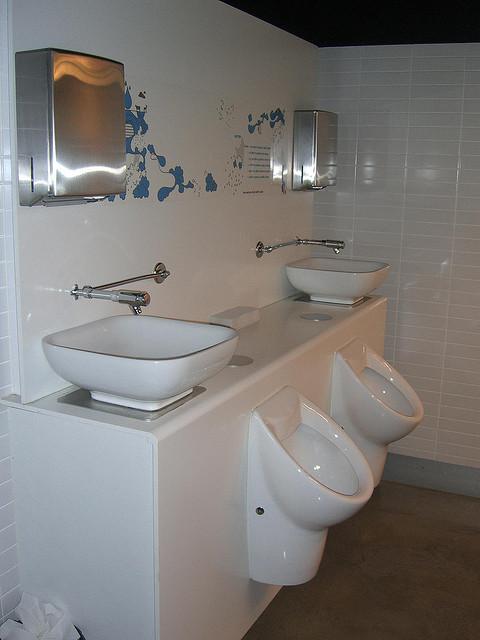What color is the bowl?
Be succinct. White. Which is the urinal?
Short answer required. Below sink. How many objects would require running water?
Write a very short answer. 4. How many urinals are there?
Quick response, please. 2. Is this a public bathroom?
Be succinct. Yes. How many sinks are there?
Quick response, please. 2. What does the toilet use to flush?
Short answer required. Water. What kind of room is this?
Give a very brief answer. Bathroom. Where is the mirror?
Be succinct. Nowhere. How many sinks are here?
Quick response, please. 2. What does the blue paint on the wall say?
Concise answer only. Nothing. What is the sink cabinet made of?
Answer briefly. Porcelain. How many people commonly use this bathroom?
Short answer required. 2. 